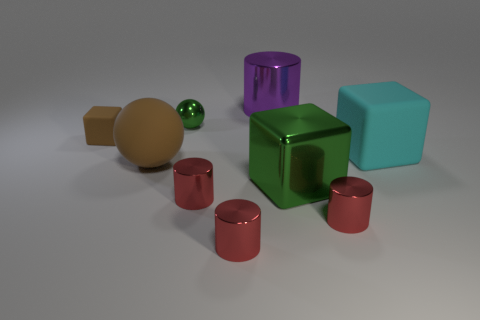There is a rubber thing that is on the right side of the metal cylinder behind the tiny rubber block; what shape is it? The object in question appears to be a cylindrical shape, constructed with a rounded surface that is consistent in diameter from top to bottom, much like that of a common drinking glass or a can. 